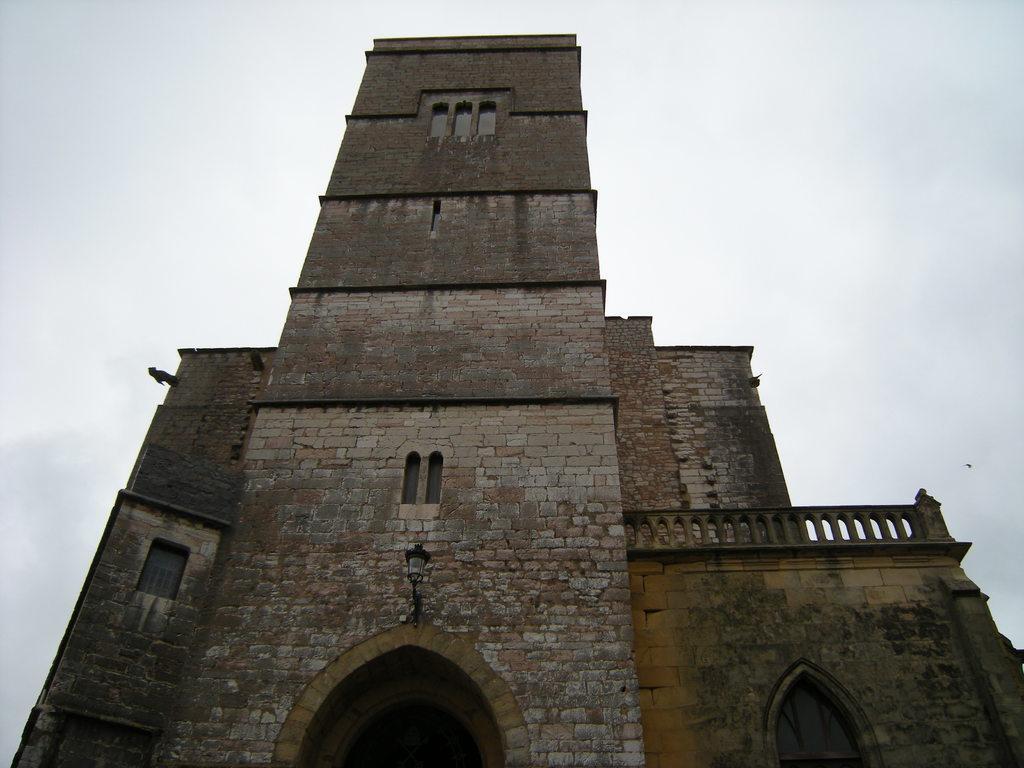In one or two sentences, can you explain what this image depicts? In this image I can see a building. At the top I can see the sky. 